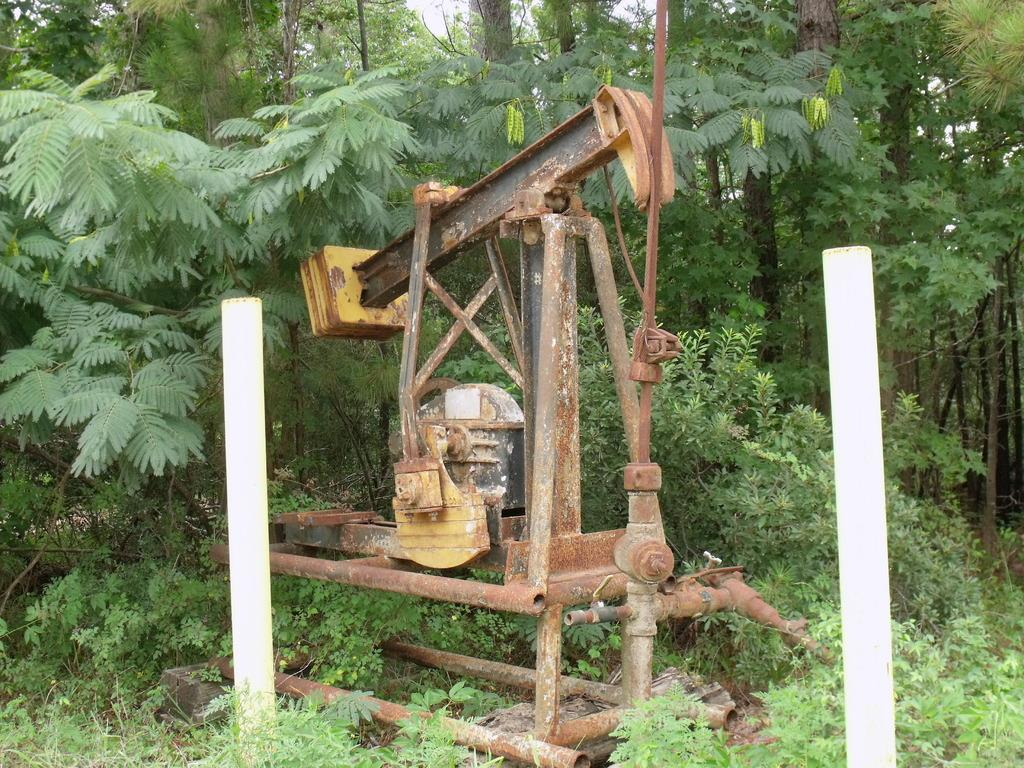What is the main object in the image? There is a machine in the image. What else can be seen in the image besides the machine? There are poles in the image. What can be seen in the background of the image? Trees are visible in the background of the image. What is visible at the top of the image? The sky is visible at the top of the image. What type of vegetation is at the bottom of the image? There are plants at the bottom of the image. How many tomatoes are hanging from the poles in the image? There are no tomatoes present in the image; only poles, a machine, trees, the sky, and plants can be seen. Is there a scarecrow wearing a hat in the image? There is no scarecrow or hat present in the image. 